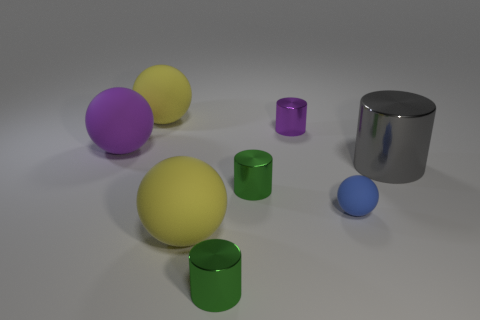What number of tiny cylinders are both on the left side of the small purple metal object and behind the tiny blue object?
Make the answer very short. 1. There is a gray thing that is the same shape as the purple metallic thing; what size is it?
Your answer should be very brief. Large. There is a green object to the right of the cylinder that is in front of the small blue sphere; what number of big purple things are left of it?
Provide a short and direct response. 1. There is a large ball that is left of the big yellow matte thing behind the big gray cylinder; what color is it?
Provide a short and direct response. Purple. How many other things are made of the same material as the blue ball?
Keep it short and to the point. 3. How many rubber balls are behind the gray shiny cylinder behind the small blue sphere?
Ensure brevity in your answer.  2. There is a big object that is in front of the tiny blue matte thing; does it have the same color as the large matte object that is behind the purple matte object?
Give a very brief answer. Yes. Is the number of purple things less than the number of tiny purple metallic objects?
Keep it short and to the point. No. There is a yellow matte thing that is behind the tiny purple cylinder to the left of the gray object; what is its shape?
Provide a short and direct response. Sphere. What shape is the big yellow object behind the yellow object that is right of the yellow sphere behind the purple cylinder?
Your response must be concise. Sphere. 